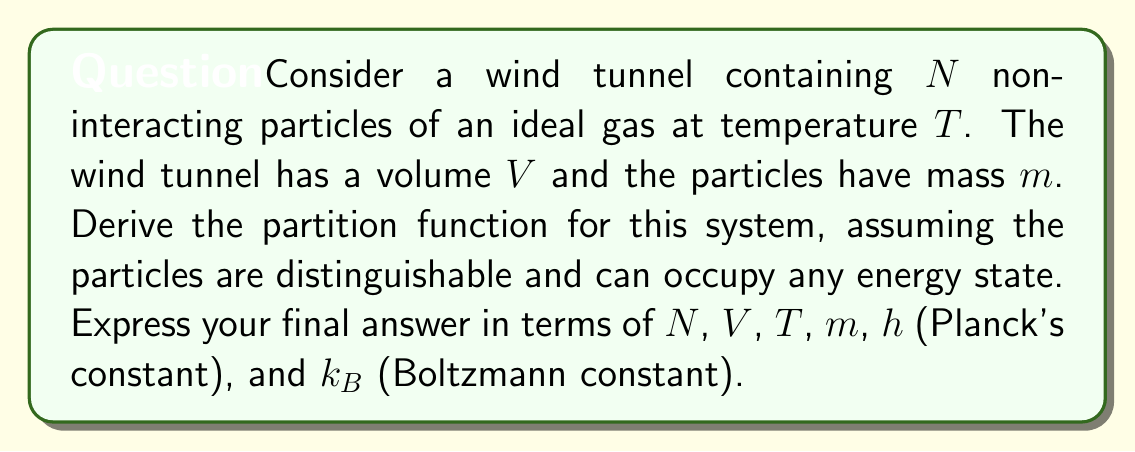Teach me how to tackle this problem. 1. For a system of distinguishable particles, the total partition function is the product of individual particle partition functions:

   $$Z = z^N$$

   where $z$ is the single-particle partition function.

2. The single-particle partition function is given by:

   $$z = \int e^{-\beta E(p,q)} \frac{d^3p d^3q}{h^3}$$

   where $\beta = \frac{1}{k_B T}$, $E(p,q)$ is the energy of a particle, $p$ is momentum, and $q$ is position.

3. For an ideal gas particle in a wind tunnel, the energy is purely kinetic:

   $$E(p) = \frac{p^2}{2m}$$

4. The position integral is simply the volume $V$. The momentum integral is:

   $$\int e^{-\beta \frac{p^2}{2m}} d^3p = \left(\frac{2\pi m}{\beta}\right)^{3/2}$$

5. Combining these results:

   $$z = V \left(\frac{2\pi m}{\beta}\right)^{3/2} \frac{1}{h^3} = V \left(\frac{2\pi m k_B T}{h^2}\right)^{3/2}$$

6. The total partition function is thus:

   $$Z = \left[V \left(\frac{2\pi m k_B T}{h^2}\right)^{3/2}\right]^N$$

7. Simplifying:

   $$Z = V^N \left(\frac{2\pi m k_B T}{h^2}\right)^{3N/2}$$
Answer: $$Z = V^N \left(\frac{2\pi m k_B T}{h^2}\right)^{3N/2}$$ 